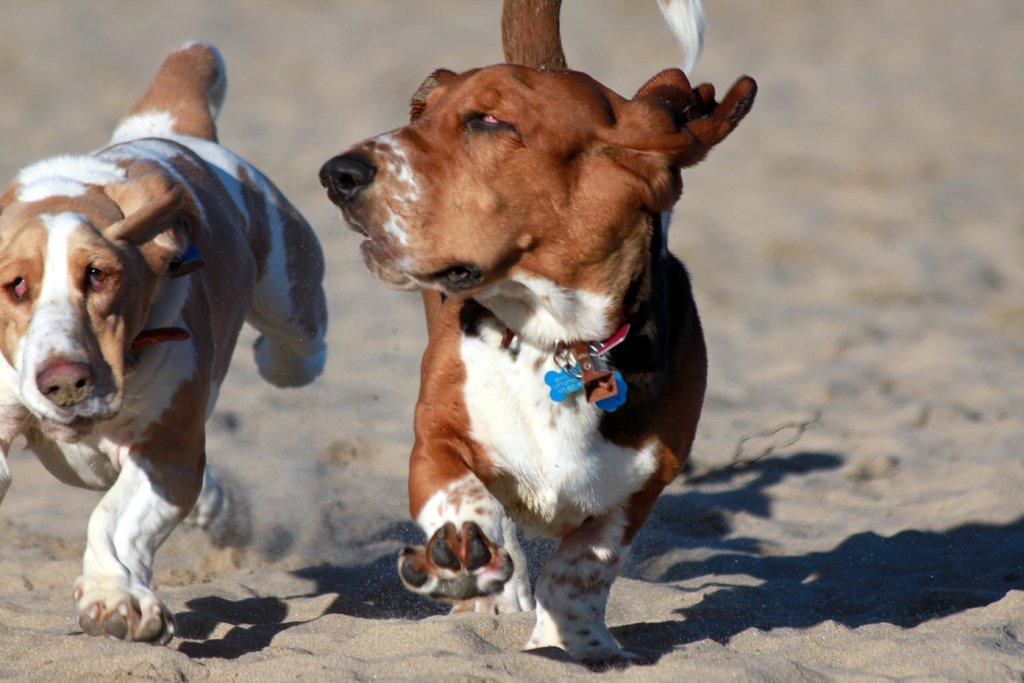How many dogs are present in the image? There are two dogs in the image. What are the dogs doing in the image? The dogs are walking in the image. What type of surface is the dogs walking on? The ground appears to be sand in the image. Is there any equipment or accessory visible on the dogs? Yes, there is a dog belt around one of the dog's necks. What type of texture can be seen on the pigs in the image? There are no pigs present in the image; it features two dogs walking on sand. How many circles can be seen in the image? There is no specific mention of circles in the image, as it primarily focuses on the dogs and their surroundings. 